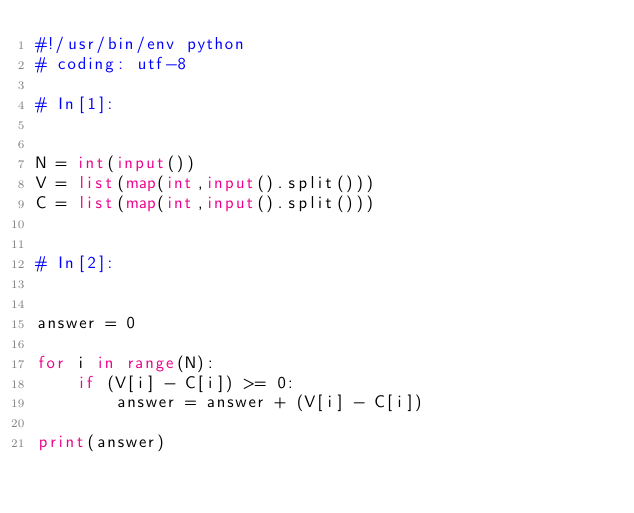<code> <loc_0><loc_0><loc_500><loc_500><_Python_>#!/usr/bin/env python
# coding: utf-8

# In[1]:


N = int(input())
V = list(map(int,input().split()))
C = list(map(int,input().split()))


# In[2]:


answer = 0

for i in range(N):
    if (V[i] - C[i]) >= 0:
        answer = answer + (V[i] - C[i])
        
print(answer)

</code> 